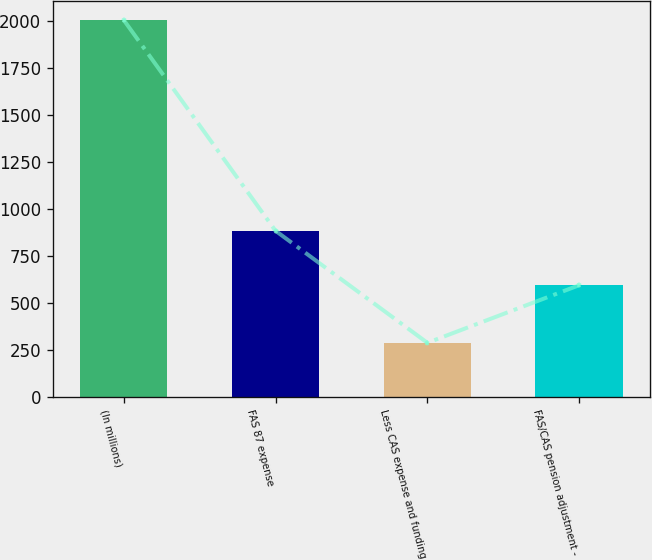Convert chart to OTSL. <chart><loc_0><loc_0><loc_500><loc_500><bar_chart><fcel>(In millions)<fcel>FAS 87 expense<fcel>Less CAS expense and funding<fcel>FAS/CAS pension adjustment -<nl><fcel>2004<fcel>884<fcel>289<fcel>595<nl></chart> 